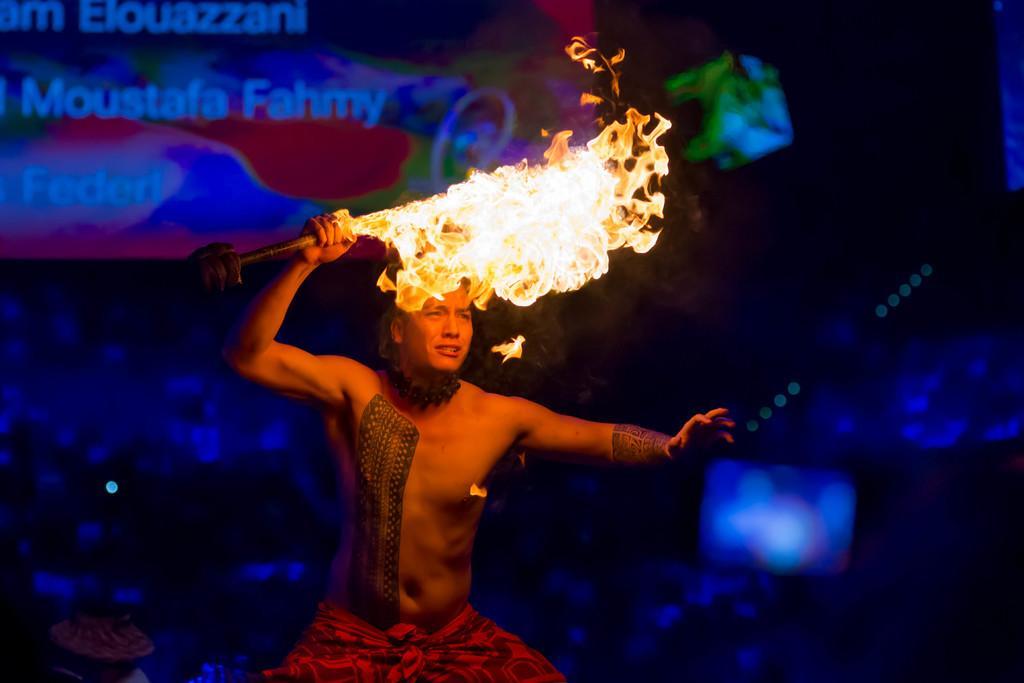Can you describe this image briefly? In this image, we can see a person is holding a stick with fire. Background we can see blur view. Top of the image, we can see a banner. On the banner, we can see some text. 